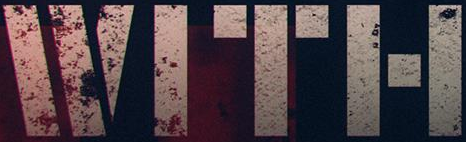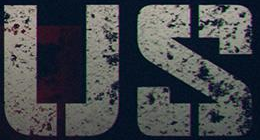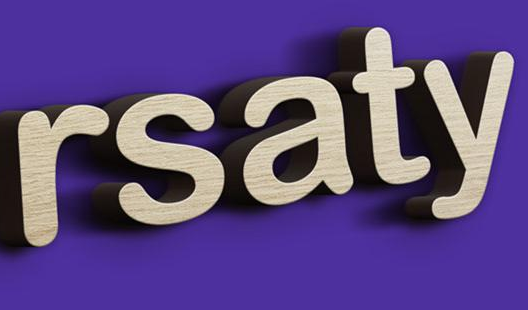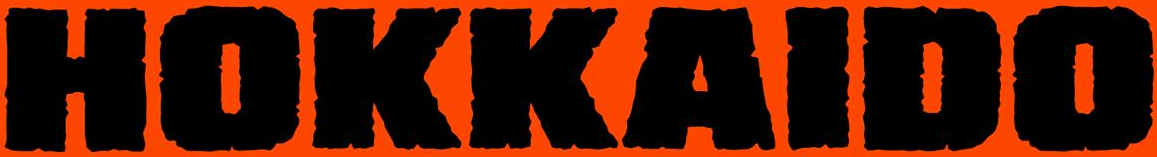What text appears in these images from left to right, separated by a semicolon? WITH; US; rsaty; HOKKAIDO 